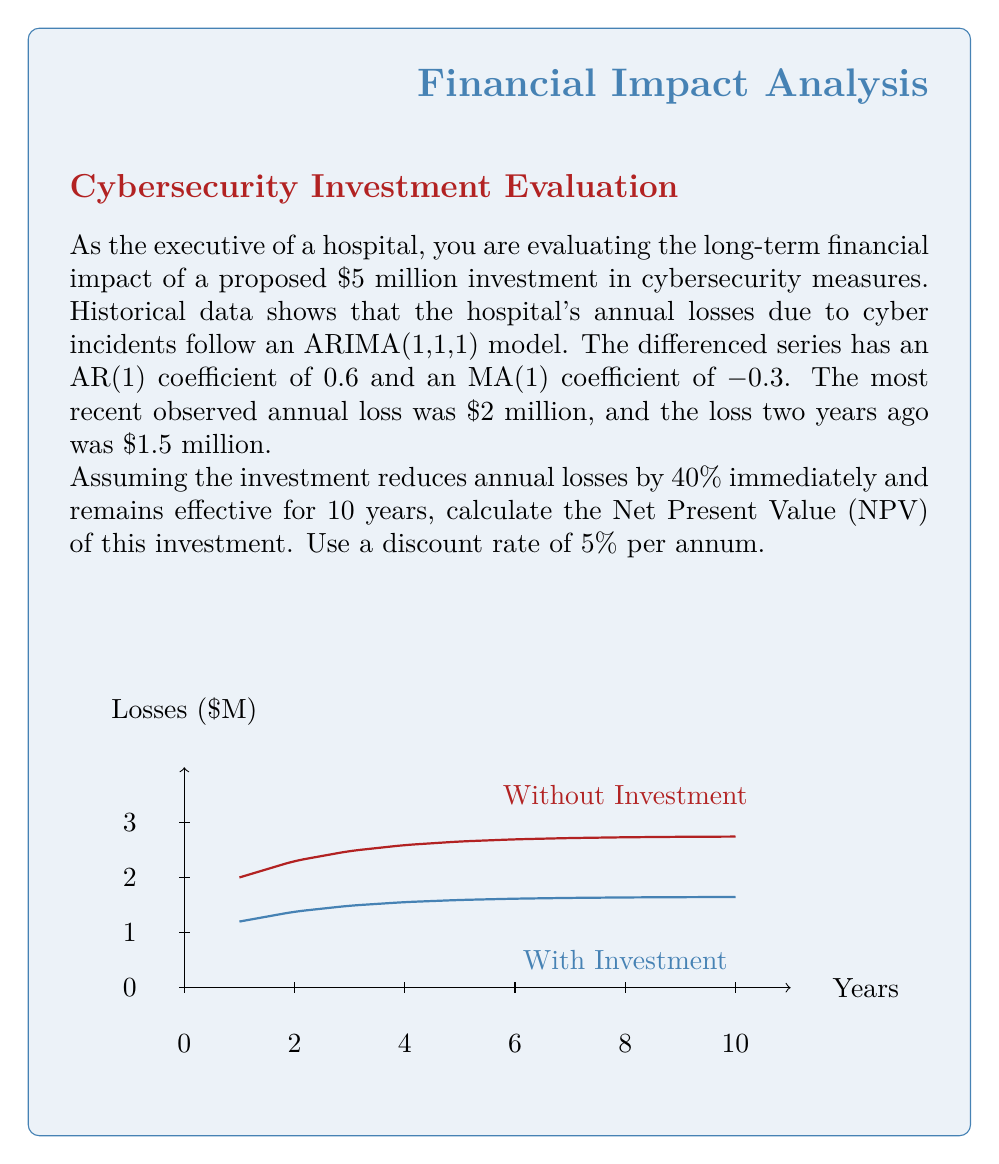Help me with this question. Let's approach this problem step-by-step:

1) First, we need to forecast the losses for the next 10 years without the investment:

   The ARIMA(1,1,1) model for the differenced series is:
   $$\Delta Y_t = 0.6\Delta Y_{t-1} + \epsilon_t - 0.3\epsilon_{t-1}$$

   Where $\Delta Y_t = Y_t - Y_{t-1}$

2) We can use this to forecast future losses:
   
   $\Delta Y_1 = Y_1 - Y_0 = 2 - 1.5 = 0.5$
   $\Delta Y_2 = 0.6(0.5) = 0.3$
   $Y_2 = Y_1 + \Delta Y_2 = 2 + 0.3 = 2.3$

   Continuing this process, we get the projected losses for 10 years.

3) Now, we apply the 40% reduction to these projected losses for the investment scenario.

4) The cash flows for NPV calculation will be the difference between these two scenarios, minus the initial investment:

   Year 0: -$5 million (initial investment)
   Year 1: $2 - $1.2 = $0.8 million
   Year 2: $2.3 - $1.38 = $0.92 million
   ...and so on.

5) We calculate the NPV using the formula:

   $$NPV = -C_0 + \sum_{t=1}^{10} \frac{C_t}{(1+r)^t}$$

   Where $C_0$ is the initial investment, $C_t$ are the cash flows, and $r$ is the discount rate.

6) Plugging in our values:

   $$NPV = -5 + \frac{0.8}{1.05} + \frac{0.92}{1.05^2} + ... + \frac{1.0958}{1.05^{10}}$$

7) Calculating this sum gives us the NPV.
Answer: $2.34 million 